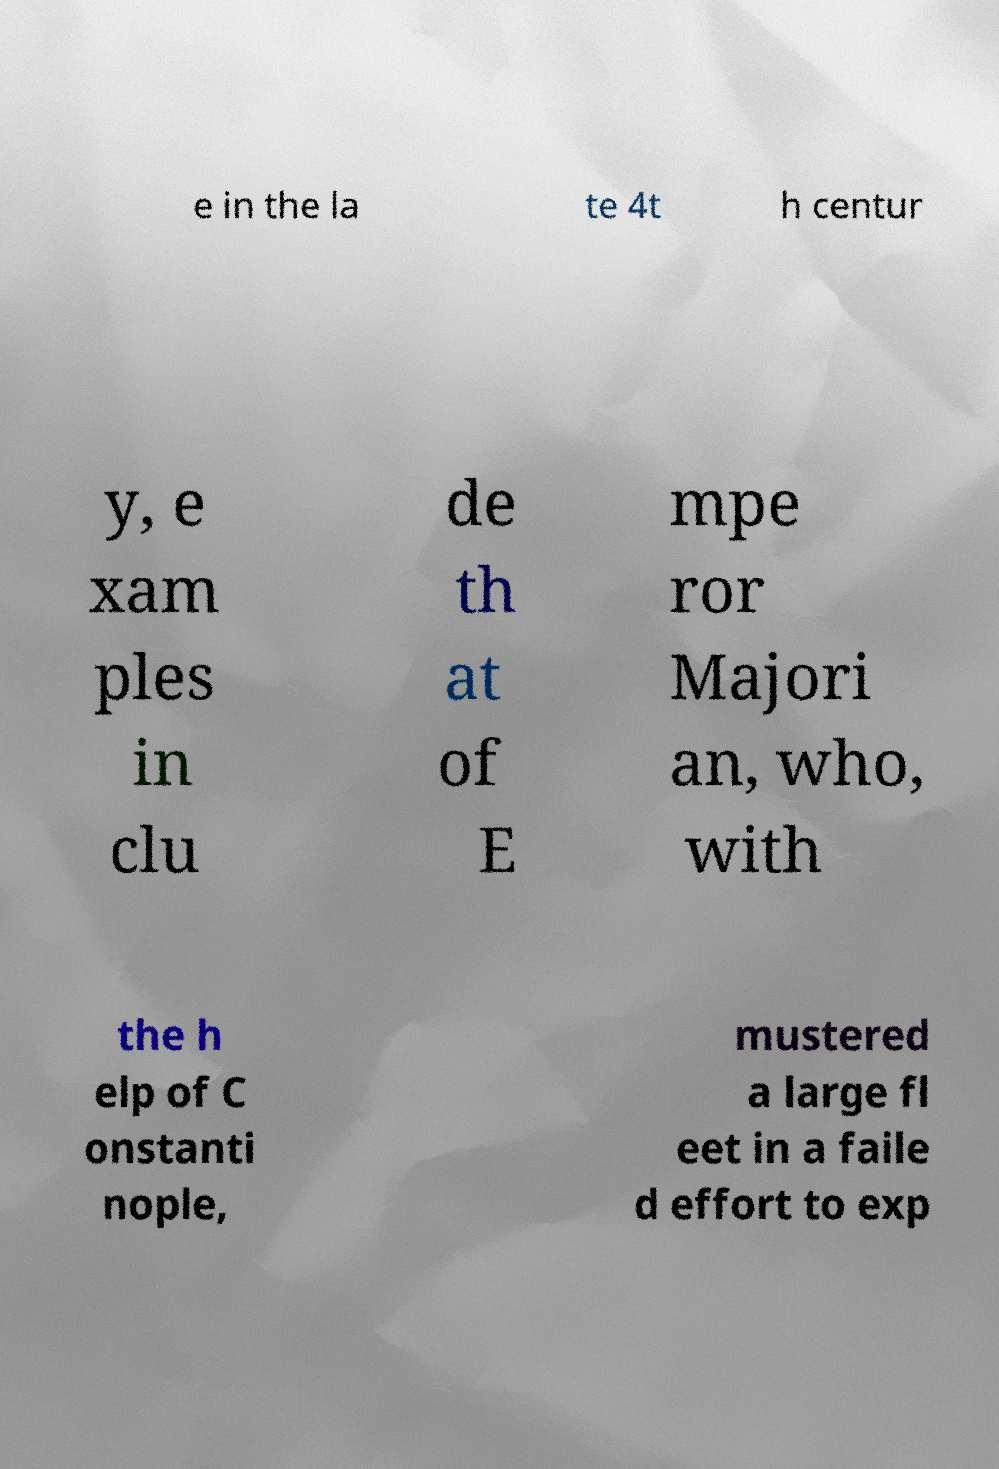I need the written content from this picture converted into text. Can you do that? e in the la te 4t h centur y, e xam ples in clu de th at of E mpe ror Majori an, who, with the h elp of C onstanti nople, mustered a large fl eet in a faile d effort to exp 